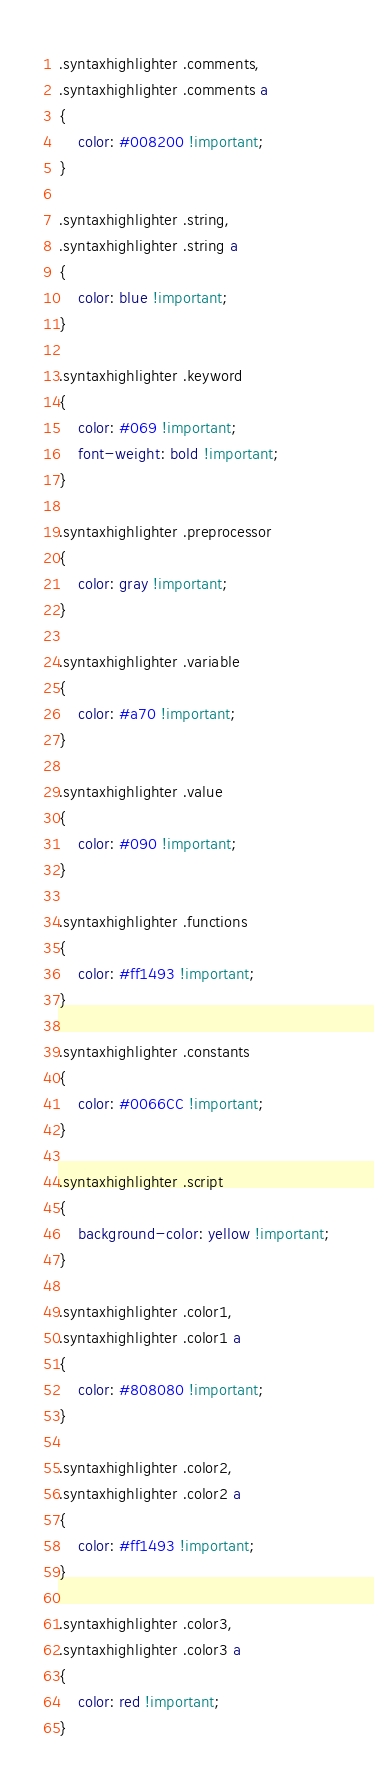Convert code to text. <code><loc_0><loc_0><loc_500><loc_500><_CSS_>.syntaxhighlighter .comments,
.syntaxhighlighter .comments a
{ 
	color: #008200 !important;
}

.syntaxhighlighter .string,
.syntaxhighlighter .string a
{
	color: blue !important; 
}

.syntaxhighlighter .keyword
{ 
	color: #069 !important; 
	font-weight: bold !important; 
}

.syntaxhighlighter .preprocessor 
{ 
	color: gray !important; 
}

.syntaxhighlighter .variable 
{ 
	color: #a70 !important; 
}

.syntaxhighlighter .value
{ 
	color: #090 !important; 
}

.syntaxhighlighter .functions
{ 
	color: #ff1493 !important; 
}

.syntaxhighlighter .constants
{ 
	color: #0066CC !important; 
}

.syntaxhighlighter .script
{ 
	background-color: yellow !important;
}

.syntaxhighlighter .color1,
.syntaxhighlighter .color1 a
{ 
	color: #808080 !important; 
}

.syntaxhighlighter .color2,
.syntaxhighlighter .color2 a
{ 
	color: #ff1493 !important; 
}

.syntaxhighlighter .color3,
.syntaxhighlighter .color3 a
{ 
	color: red !important; 
}
</code> 